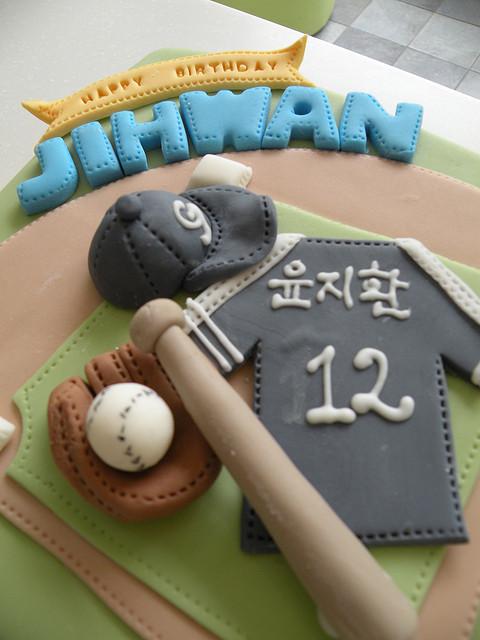What is this?
Quick response, please. Cake. Is this cake probably for a boy or a girl?
Concise answer only. Boy. What number is on the jersey?
Short answer required. 12. How many balls in the picture?
Be succinct. 1. 